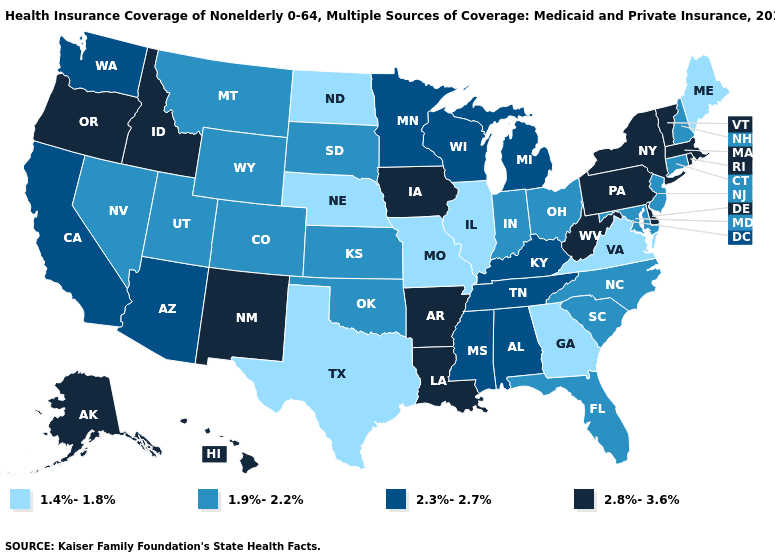Does Hawaii have a lower value than Tennessee?
Write a very short answer. No. Name the states that have a value in the range 2.3%-2.7%?
Keep it brief. Alabama, Arizona, California, Kentucky, Michigan, Minnesota, Mississippi, Tennessee, Washington, Wisconsin. Name the states that have a value in the range 1.9%-2.2%?
Give a very brief answer. Colorado, Connecticut, Florida, Indiana, Kansas, Maryland, Montana, Nevada, New Hampshire, New Jersey, North Carolina, Ohio, Oklahoma, South Carolina, South Dakota, Utah, Wyoming. Among the states that border North Carolina , which have the highest value?
Short answer required. Tennessee. What is the value of Idaho?
Keep it brief. 2.8%-3.6%. Which states hav the highest value in the Northeast?
Concise answer only. Massachusetts, New York, Pennsylvania, Rhode Island, Vermont. Which states have the lowest value in the South?
Answer briefly. Georgia, Texas, Virginia. Name the states that have a value in the range 2.3%-2.7%?
Short answer required. Alabama, Arizona, California, Kentucky, Michigan, Minnesota, Mississippi, Tennessee, Washington, Wisconsin. What is the highest value in the USA?
Keep it brief. 2.8%-3.6%. Does the first symbol in the legend represent the smallest category?
Concise answer only. Yes. Does North Dakota have the lowest value in the USA?
Answer briefly. Yes. Name the states that have a value in the range 1.4%-1.8%?
Be succinct. Georgia, Illinois, Maine, Missouri, Nebraska, North Dakota, Texas, Virginia. Name the states that have a value in the range 2.3%-2.7%?
Concise answer only. Alabama, Arizona, California, Kentucky, Michigan, Minnesota, Mississippi, Tennessee, Washington, Wisconsin. Does Connecticut have a higher value than North Dakota?
Give a very brief answer. Yes. Name the states that have a value in the range 1.9%-2.2%?
Be succinct. Colorado, Connecticut, Florida, Indiana, Kansas, Maryland, Montana, Nevada, New Hampshire, New Jersey, North Carolina, Ohio, Oklahoma, South Carolina, South Dakota, Utah, Wyoming. 